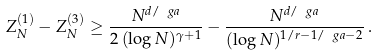<formula> <loc_0><loc_0><loc_500><loc_500>Z _ { N } ^ { ( 1 ) } - Z _ { N } ^ { ( 3 ) } \geq \frac { N ^ { d / \ g a } } { 2 \, ( \log N ) ^ { \gamma + 1 } } - \frac { N ^ { d / \ g a } } { ( \log N ) ^ { 1 / r - 1 / \ g a - 2 } } \, .</formula> 